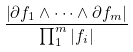Convert formula to latex. <formula><loc_0><loc_0><loc_500><loc_500>\frac { \left | \partial f _ { 1 } \wedge \dots \wedge \partial f _ { m } \right | } { \prod _ { 1 } ^ { m } | f _ { i } | }</formula> 